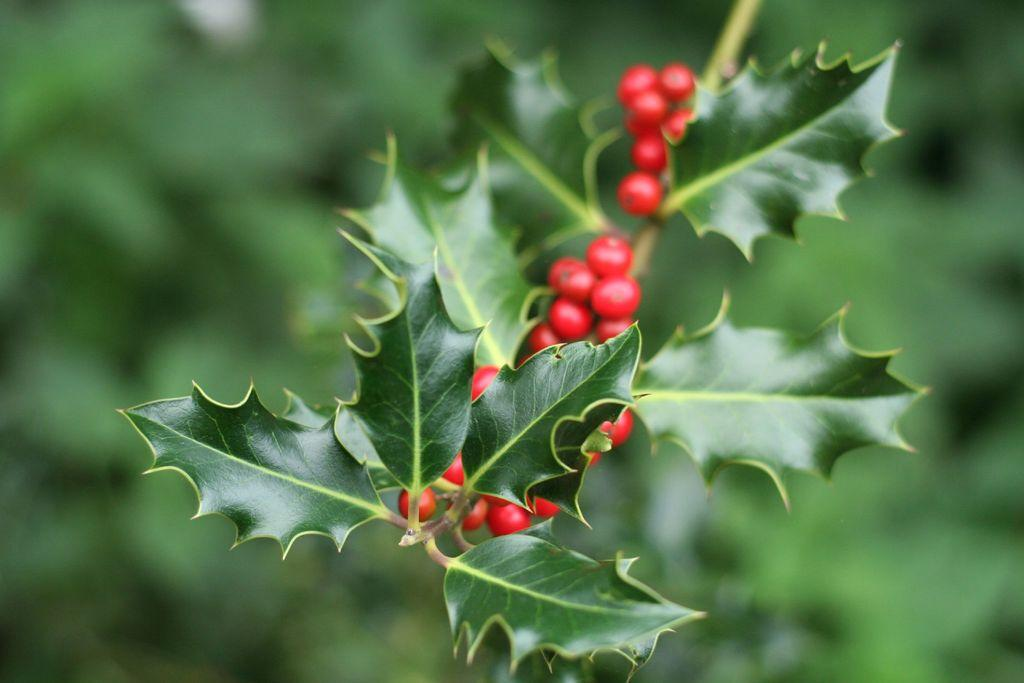What type of vegetation can be seen in the image? There are leaves in the image. What else is present in the image besides leaves? There are fruits in the image. What color are the fruits? The fruits are red in color. Can you describe the background of the image? The background of the image is blurred. What type of crime is being committed in the image? There is no crime present in the image; it features leaves and red fruits with a blurred background. Can you see a snake in the image? There is no snake present in the image. 